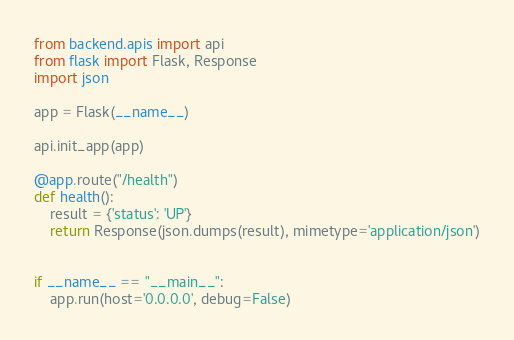Convert code to text. <code><loc_0><loc_0><loc_500><loc_500><_Python_>from backend.apis import api
from flask import Flask, Response
import json

app = Flask(__name__)

api.init_app(app)

@app.route("/health")
def health():
    result = {'status': 'UP'}
    return Response(json.dumps(result), mimetype='application/json')


if __name__ == "__main__":
    app.run(host='0.0.0.0', debug=False)
</code> 